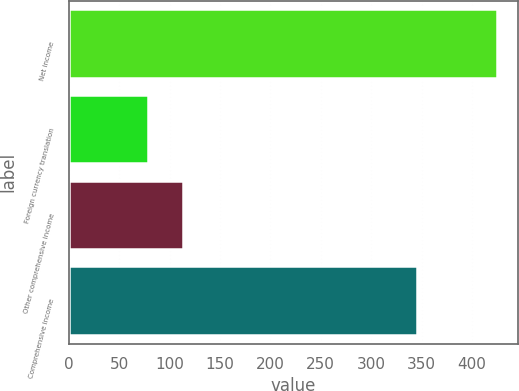Convert chart to OTSL. <chart><loc_0><loc_0><loc_500><loc_500><bar_chart><fcel>Net income<fcel>Foreign currency translation<fcel>Other comprehensive income<fcel>Comprehensive income<nl><fcel>424.4<fcel>78.5<fcel>113.09<fcel>345.9<nl></chart> 